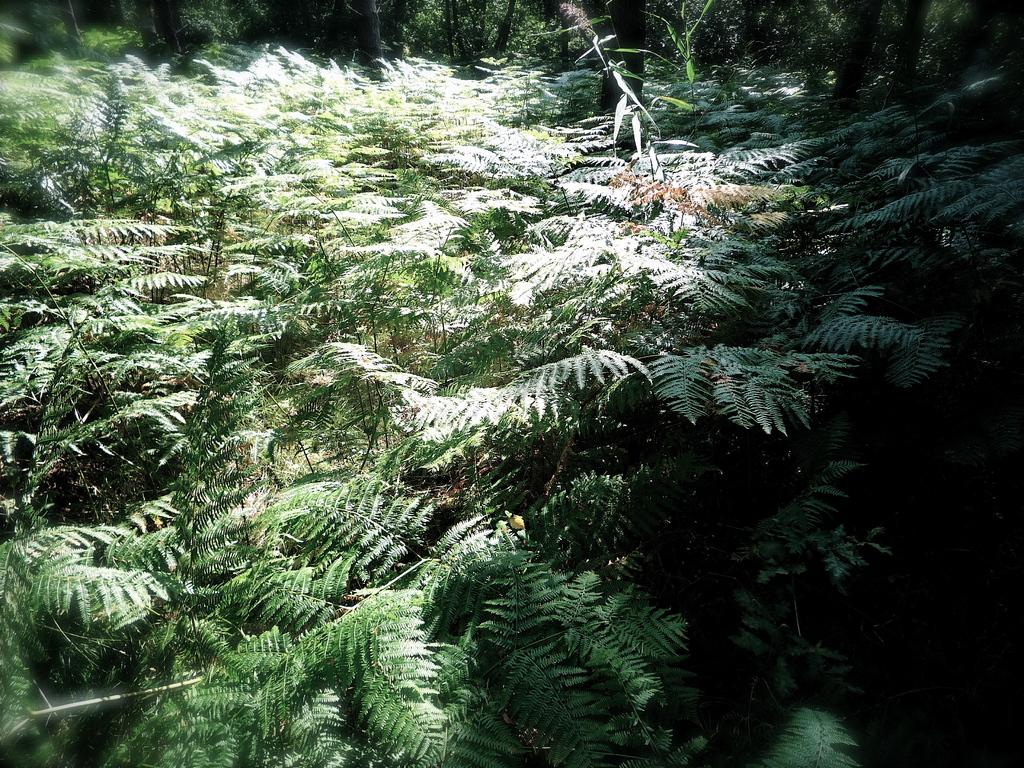What is the primary feature of the image? There are many trees in the image. Can you describe the setting of the image? The image features a natural environment with a significant number of trees. What type of vegetation is visible in the image? The image primarily shows trees. What type of owl can be seen perched on the wrench in the image? There is no owl or wrench present in the image; it only features trees. 